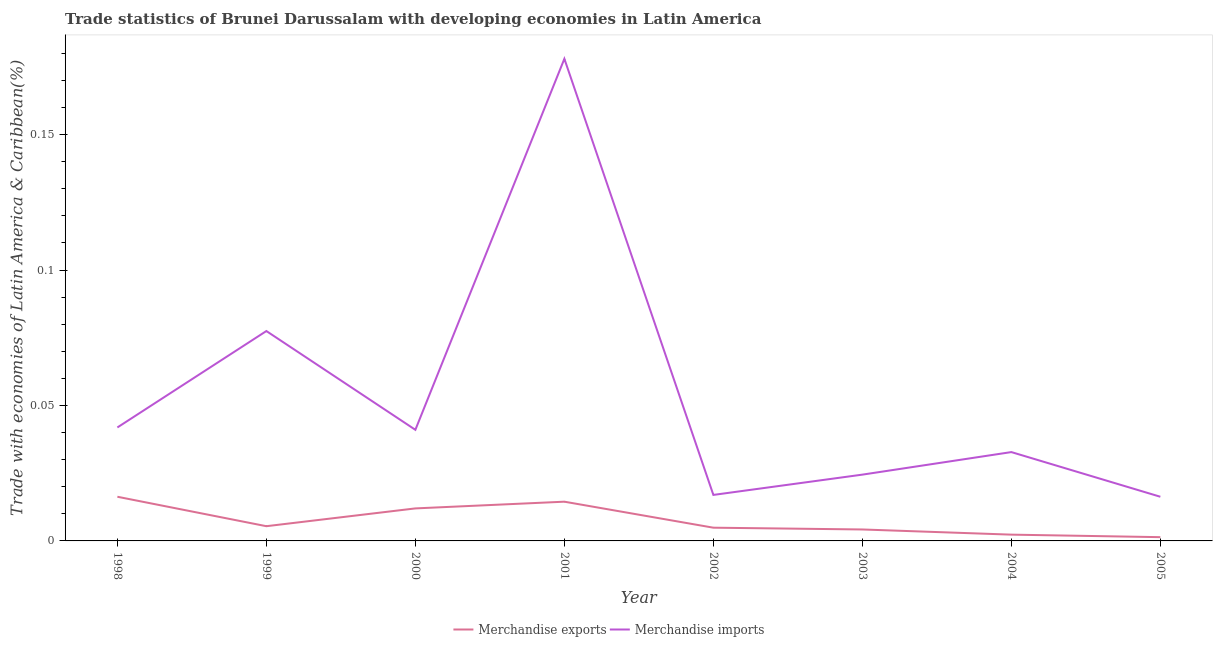Is the number of lines equal to the number of legend labels?
Your answer should be compact. Yes. What is the merchandise imports in 2000?
Ensure brevity in your answer.  0.04. Across all years, what is the maximum merchandise exports?
Your answer should be very brief. 0.02. Across all years, what is the minimum merchandise imports?
Make the answer very short. 0.02. What is the total merchandise imports in the graph?
Provide a succinct answer. 0.43. What is the difference between the merchandise imports in 1999 and that in 2000?
Keep it short and to the point. 0.04. What is the difference between the merchandise imports in 2002 and the merchandise exports in 2001?
Keep it short and to the point. 0. What is the average merchandise exports per year?
Your answer should be compact. 0.01. In the year 2004, what is the difference between the merchandise exports and merchandise imports?
Offer a terse response. -0.03. What is the ratio of the merchandise imports in 2001 to that in 2003?
Provide a short and direct response. 7.27. Is the merchandise exports in 2000 less than that in 2002?
Your answer should be compact. No. What is the difference between the highest and the second highest merchandise imports?
Offer a very short reply. 0.1. What is the difference between the highest and the lowest merchandise exports?
Ensure brevity in your answer.  0.01. In how many years, is the merchandise exports greater than the average merchandise exports taken over all years?
Ensure brevity in your answer.  3. Is the sum of the merchandise imports in 1999 and 2004 greater than the maximum merchandise exports across all years?
Provide a succinct answer. Yes. Is the merchandise exports strictly greater than the merchandise imports over the years?
Provide a short and direct response. No. Is the merchandise imports strictly less than the merchandise exports over the years?
Make the answer very short. No. How many lines are there?
Your answer should be very brief. 2. How many years are there in the graph?
Give a very brief answer. 8. What is the difference between two consecutive major ticks on the Y-axis?
Provide a short and direct response. 0.05. Where does the legend appear in the graph?
Make the answer very short. Bottom center. How are the legend labels stacked?
Provide a succinct answer. Horizontal. What is the title of the graph?
Offer a terse response. Trade statistics of Brunei Darussalam with developing economies in Latin America. Does "Fixed telephone" appear as one of the legend labels in the graph?
Give a very brief answer. No. What is the label or title of the Y-axis?
Offer a terse response. Trade with economies of Latin America & Caribbean(%). What is the Trade with economies of Latin America & Caribbean(%) of Merchandise exports in 1998?
Offer a very short reply. 0.02. What is the Trade with economies of Latin America & Caribbean(%) in Merchandise imports in 1998?
Ensure brevity in your answer.  0.04. What is the Trade with economies of Latin America & Caribbean(%) in Merchandise exports in 1999?
Offer a terse response. 0.01. What is the Trade with economies of Latin America & Caribbean(%) in Merchandise imports in 1999?
Make the answer very short. 0.08. What is the Trade with economies of Latin America & Caribbean(%) of Merchandise exports in 2000?
Provide a short and direct response. 0.01. What is the Trade with economies of Latin America & Caribbean(%) in Merchandise imports in 2000?
Your response must be concise. 0.04. What is the Trade with economies of Latin America & Caribbean(%) of Merchandise exports in 2001?
Provide a succinct answer. 0.01. What is the Trade with economies of Latin America & Caribbean(%) in Merchandise imports in 2001?
Give a very brief answer. 0.18. What is the Trade with economies of Latin America & Caribbean(%) of Merchandise exports in 2002?
Provide a short and direct response. 0. What is the Trade with economies of Latin America & Caribbean(%) in Merchandise imports in 2002?
Provide a short and direct response. 0.02. What is the Trade with economies of Latin America & Caribbean(%) in Merchandise exports in 2003?
Your answer should be compact. 0. What is the Trade with economies of Latin America & Caribbean(%) of Merchandise imports in 2003?
Ensure brevity in your answer.  0.02. What is the Trade with economies of Latin America & Caribbean(%) in Merchandise exports in 2004?
Offer a very short reply. 0. What is the Trade with economies of Latin America & Caribbean(%) in Merchandise imports in 2004?
Offer a very short reply. 0.03. What is the Trade with economies of Latin America & Caribbean(%) in Merchandise exports in 2005?
Ensure brevity in your answer.  0. What is the Trade with economies of Latin America & Caribbean(%) in Merchandise imports in 2005?
Your response must be concise. 0.02. Across all years, what is the maximum Trade with economies of Latin America & Caribbean(%) of Merchandise exports?
Offer a very short reply. 0.02. Across all years, what is the maximum Trade with economies of Latin America & Caribbean(%) in Merchandise imports?
Give a very brief answer. 0.18. Across all years, what is the minimum Trade with economies of Latin America & Caribbean(%) of Merchandise exports?
Keep it short and to the point. 0. Across all years, what is the minimum Trade with economies of Latin America & Caribbean(%) of Merchandise imports?
Provide a short and direct response. 0.02. What is the total Trade with economies of Latin America & Caribbean(%) in Merchandise exports in the graph?
Provide a succinct answer. 0.06. What is the total Trade with economies of Latin America & Caribbean(%) of Merchandise imports in the graph?
Offer a very short reply. 0.43. What is the difference between the Trade with economies of Latin America & Caribbean(%) of Merchandise exports in 1998 and that in 1999?
Your response must be concise. 0.01. What is the difference between the Trade with economies of Latin America & Caribbean(%) in Merchandise imports in 1998 and that in 1999?
Your answer should be very brief. -0.04. What is the difference between the Trade with economies of Latin America & Caribbean(%) in Merchandise exports in 1998 and that in 2000?
Your answer should be very brief. 0. What is the difference between the Trade with economies of Latin America & Caribbean(%) in Merchandise imports in 1998 and that in 2000?
Ensure brevity in your answer.  0. What is the difference between the Trade with economies of Latin America & Caribbean(%) of Merchandise exports in 1998 and that in 2001?
Provide a succinct answer. 0. What is the difference between the Trade with economies of Latin America & Caribbean(%) in Merchandise imports in 1998 and that in 2001?
Offer a very short reply. -0.14. What is the difference between the Trade with economies of Latin America & Caribbean(%) in Merchandise exports in 1998 and that in 2002?
Ensure brevity in your answer.  0.01. What is the difference between the Trade with economies of Latin America & Caribbean(%) in Merchandise imports in 1998 and that in 2002?
Provide a succinct answer. 0.02. What is the difference between the Trade with economies of Latin America & Caribbean(%) of Merchandise exports in 1998 and that in 2003?
Provide a short and direct response. 0.01. What is the difference between the Trade with economies of Latin America & Caribbean(%) in Merchandise imports in 1998 and that in 2003?
Ensure brevity in your answer.  0.02. What is the difference between the Trade with economies of Latin America & Caribbean(%) in Merchandise exports in 1998 and that in 2004?
Your answer should be very brief. 0.01. What is the difference between the Trade with economies of Latin America & Caribbean(%) of Merchandise imports in 1998 and that in 2004?
Your answer should be very brief. 0.01. What is the difference between the Trade with economies of Latin America & Caribbean(%) of Merchandise exports in 1998 and that in 2005?
Ensure brevity in your answer.  0.01. What is the difference between the Trade with economies of Latin America & Caribbean(%) of Merchandise imports in 1998 and that in 2005?
Keep it short and to the point. 0.03. What is the difference between the Trade with economies of Latin America & Caribbean(%) in Merchandise exports in 1999 and that in 2000?
Your response must be concise. -0.01. What is the difference between the Trade with economies of Latin America & Caribbean(%) in Merchandise imports in 1999 and that in 2000?
Provide a short and direct response. 0.04. What is the difference between the Trade with economies of Latin America & Caribbean(%) in Merchandise exports in 1999 and that in 2001?
Provide a succinct answer. -0.01. What is the difference between the Trade with economies of Latin America & Caribbean(%) in Merchandise imports in 1999 and that in 2001?
Make the answer very short. -0.1. What is the difference between the Trade with economies of Latin America & Caribbean(%) in Merchandise exports in 1999 and that in 2002?
Your answer should be compact. 0. What is the difference between the Trade with economies of Latin America & Caribbean(%) in Merchandise imports in 1999 and that in 2002?
Your answer should be compact. 0.06. What is the difference between the Trade with economies of Latin America & Caribbean(%) of Merchandise exports in 1999 and that in 2003?
Your answer should be compact. 0. What is the difference between the Trade with economies of Latin America & Caribbean(%) of Merchandise imports in 1999 and that in 2003?
Your response must be concise. 0.05. What is the difference between the Trade with economies of Latin America & Caribbean(%) of Merchandise exports in 1999 and that in 2004?
Offer a very short reply. 0. What is the difference between the Trade with economies of Latin America & Caribbean(%) of Merchandise imports in 1999 and that in 2004?
Offer a terse response. 0.04. What is the difference between the Trade with economies of Latin America & Caribbean(%) in Merchandise exports in 1999 and that in 2005?
Make the answer very short. 0. What is the difference between the Trade with economies of Latin America & Caribbean(%) in Merchandise imports in 1999 and that in 2005?
Ensure brevity in your answer.  0.06. What is the difference between the Trade with economies of Latin America & Caribbean(%) in Merchandise exports in 2000 and that in 2001?
Offer a terse response. -0. What is the difference between the Trade with economies of Latin America & Caribbean(%) in Merchandise imports in 2000 and that in 2001?
Keep it short and to the point. -0.14. What is the difference between the Trade with economies of Latin America & Caribbean(%) in Merchandise exports in 2000 and that in 2002?
Provide a short and direct response. 0.01. What is the difference between the Trade with economies of Latin America & Caribbean(%) in Merchandise imports in 2000 and that in 2002?
Your answer should be very brief. 0.02. What is the difference between the Trade with economies of Latin America & Caribbean(%) in Merchandise exports in 2000 and that in 2003?
Offer a very short reply. 0.01. What is the difference between the Trade with economies of Latin America & Caribbean(%) of Merchandise imports in 2000 and that in 2003?
Provide a succinct answer. 0.02. What is the difference between the Trade with economies of Latin America & Caribbean(%) of Merchandise exports in 2000 and that in 2004?
Offer a very short reply. 0.01. What is the difference between the Trade with economies of Latin America & Caribbean(%) of Merchandise imports in 2000 and that in 2004?
Your answer should be very brief. 0.01. What is the difference between the Trade with economies of Latin America & Caribbean(%) in Merchandise exports in 2000 and that in 2005?
Your answer should be very brief. 0.01. What is the difference between the Trade with economies of Latin America & Caribbean(%) of Merchandise imports in 2000 and that in 2005?
Provide a succinct answer. 0.02. What is the difference between the Trade with economies of Latin America & Caribbean(%) of Merchandise exports in 2001 and that in 2002?
Give a very brief answer. 0.01. What is the difference between the Trade with economies of Latin America & Caribbean(%) in Merchandise imports in 2001 and that in 2002?
Give a very brief answer. 0.16. What is the difference between the Trade with economies of Latin America & Caribbean(%) of Merchandise exports in 2001 and that in 2003?
Provide a succinct answer. 0.01. What is the difference between the Trade with economies of Latin America & Caribbean(%) of Merchandise imports in 2001 and that in 2003?
Give a very brief answer. 0.15. What is the difference between the Trade with economies of Latin America & Caribbean(%) in Merchandise exports in 2001 and that in 2004?
Your answer should be very brief. 0.01. What is the difference between the Trade with economies of Latin America & Caribbean(%) of Merchandise imports in 2001 and that in 2004?
Offer a terse response. 0.15. What is the difference between the Trade with economies of Latin America & Caribbean(%) of Merchandise exports in 2001 and that in 2005?
Provide a succinct answer. 0.01. What is the difference between the Trade with economies of Latin America & Caribbean(%) in Merchandise imports in 2001 and that in 2005?
Give a very brief answer. 0.16. What is the difference between the Trade with economies of Latin America & Caribbean(%) in Merchandise exports in 2002 and that in 2003?
Your response must be concise. 0. What is the difference between the Trade with economies of Latin America & Caribbean(%) of Merchandise imports in 2002 and that in 2003?
Offer a terse response. -0.01. What is the difference between the Trade with economies of Latin America & Caribbean(%) of Merchandise exports in 2002 and that in 2004?
Ensure brevity in your answer.  0. What is the difference between the Trade with economies of Latin America & Caribbean(%) in Merchandise imports in 2002 and that in 2004?
Provide a succinct answer. -0.02. What is the difference between the Trade with economies of Latin America & Caribbean(%) of Merchandise exports in 2002 and that in 2005?
Provide a short and direct response. 0. What is the difference between the Trade with economies of Latin America & Caribbean(%) in Merchandise imports in 2002 and that in 2005?
Offer a very short reply. 0. What is the difference between the Trade with economies of Latin America & Caribbean(%) of Merchandise exports in 2003 and that in 2004?
Provide a succinct answer. 0. What is the difference between the Trade with economies of Latin America & Caribbean(%) in Merchandise imports in 2003 and that in 2004?
Offer a terse response. -0.01. What is the difference between the Trade with economies of Latin America & Caribbean(%) of Merchandise exports in 2003 and that in 2005?
Provide a short and direct response. 0. What is the difference between the Trade with economies of Latin America & Caribbean(%) in Merchandise imports in 2003 and that in 2005?
Provide a succinct answer. 0.01. What is the difference between the Trade with economies of Latin America & Caribbean(%) of Merchandise exports in 2004 and that in 2005?
Your answer should be compact. 0. What is the difference between the Trade with economies of Latin America & Caribbean(%) in Merchandise imports in 2004 and that in 2005?
Your answer should be compact. 0.02. What is the difference between the Trade with economies of Latin America & Caribbean(%) of Merchandise exports in 1998 and the Trade with economies of Latin America & Caribbean(%) of Merchandise imports in 1999?
Your answer should be compact. -0.06. What is the difference between the Trade with economies of Latin America & Caribbean(%) of Merchandise exports in 1998 and the Trade with economies of Latin America & Caribbean(%) of Merchandise imports in 2000?
Give a very brief answer. -0.02. What is the difference between the Trade with economies of Latin America & Caribbean(%) of Merchandise exports in 1998 and the Trade with economies of Latin America & Caribbean(%) of Merchandise imports in 2001?
Provide a succinct answer. -0.16. What is the difference between the Trade with economies of Latin America & Caribbean(%) in Merchandise exports in 1998 and the Trade with economies of Latin America & Caribbean(%) in Merchandise imports in 2002?
Your answer should be very brief. -0. What is the difference between the Trade with economies of Latin America & Caribbean(%) of Merchandise exports in 1998 and the Trade with economies of Latin America & Caribbean(%) of Merchandise imports in 2003?
Keep it short and to the point. -0.01. What is the difference between the Trade with economies of Latin America & Caribbean(%) in Merchandise exports in 1998 and the Trade with economies of Latin America & Caribbean(%) in Merchandise imports in 2004?
Keep it short and to the point. -0.02. What is the difference between the Trade with economies of Latin America & Caribbean(%) in Merchandise exports in 1998 and the Trade with economies of Latin America & Caribbean(%) in Merchandise imports in 2005?
Make the answer very short. 0. What is the difference between the Trade with economies of Latin America & Caribbean(%) of Merchandise exports in 1999 and the Trade with economies of Latin America & Caribbean(%) of Merchandise imports in 2000?
Your response must be concise. -0.04. What is the difference between the Trade with economies of Latin America & Caribbean(%) of Merchandise exports in 1999 and the Trade with economies of Latin America & Caribbean(%) of Merchandise imports in 2001?
Offer a very short reply. -0.17. What is the difference between the Trade with economies of Latin America & Caribbean(%) in Merchandise exports in 1999 and the Trade with economies of Latin America & Caribbean(%) in Merchandise imports in 2002?
Your answer should be very brief. -0.01. What is the difference between the Trade with economies of Latin America & Caribbean(%) in Merchandise exports in 1999 and the Trade with economies of Latin America & Caribbean(%) in Merchandise imports in 2003?
Provide a short and direct response. -0.02. What is the difference between the Trade with economies of Latin America & Caribbean(%) of Merchandise exports in 1999 and the Trade with economies of Latin America & Caribbean(%) of Merchandise imports in 2004?
Make the answer very short. -0.03. What is the difference between the Trade with economies of Latin America & Caribbean(%) of Merchandise exports in 1999 and the Trade with economies of Latin America & Caribbean(%) of Merchandise imports in 2005?
Offer a terse response. -0.01. What is the difference between the Trade with economies of Latin America & Caribbean(%) in Merchandise exports in 2000 and the Trade with economies of Latin America & Caribbean(%) in Merchandise imports in 2001?
Give a very brief answer. -0.17. What is the difference between the Trade with economies of Latin America & Caribbean(%) in Merchandise exports in 2000 and the Trade with economies of Latin America & Caribbean(%) in Merchandise imports in 2002?
Offer a terse response. -0.01. What is the difference between the Trade with economies of Latin America & Caribbean(%) in Merchandise exports in 2000 and the Trade with economies of Latin America & Caribbean(%) in Merchandise imports in 2003?
Your response must be concise. -0.01. What is the difference between the Trade with economies of Latin America & Caribbean(%) in Merchandise exports in 2000 and the Trade with economies of Latin America & Caribbean(%) in Merchandise imports in 2004?
Your answer should be very brief. -0.02. What is the difference between the Trade with economies of Latin America & Caribbean(%) in Merchandise exports in 2000 and the Trade with economies of Latin America & Caribbean(%) in Merchandise imports in 2005?
Offer a very short reply. -0. What is the difference between the Trade with economies of Latin America & Caribbean(%) in Merchandise exports in 2001 and the Trade with economies of Latin America & Caribbean(%) in Merchandise imports in 2002?
Make the answer very short. -0. What is the difference between the Trade with economies of Latin America & Caribbean(%) in Merchandise exports in 2001 and the Trade with economies of Latin America & Caribbean(%) in Merchandise imports in 2003?
Ensure brevity in your answer.  -0.01. What is the difference between the Trade with economies of Latin America & Caribbean(%) in Merchandise exports in 2001 and the Trade with economies of Latin America & Caribbean(%) in Merchandise imports in 2004?
Make the answer very short. -0.02. What is the difference between the Trade with economies of Latin America & Caribbean(%) in Merchandise exports in 2001 and the Trade with economies of Latin America & Caribbean(%) in Merchandise imports in 2005?
Give a very brief answer. -0. What is the difference between the Trade with economies of Latin America & Caribbean(%) in Merchandise exports in 2002 and the Trade with economies of Latin America & Caribbean(%) in Merchandise imports in 2003?
Your answer should be very brief. -0.02. What is the difference between the Trade with economies of Latin America & Caribbean(%) of Merchandise exports in 2002 and the Trade with economies of Latin America & Caribbean(%) of Merchandise imports in 2004?
Your response must be concise. -0.03. What is the difference between the Trade with economies of Latin America & Caribbean(%) of Merchandise exports in 2002 and the Trade with economies of Latin America & Caribbean(%) of Merchandise imports in 2005?
Your answer should be very brief. -0.01. What is the difference between the Trade with economies of Latin America & Caribbean(%) in Merchandise exports in 2003 and the Trade with economies of Latin America & Caribbean(%) in Merchandise imports in 2004?
Make the answer very short. -0.03. What is the difference between the Trade with economies of Latin America & Caribbean(%) in Merchandise exports in 2003 and the Trade with economies of Latin America & Caribbean(%) in Merchandise imports in 2005?
Keep it short and to the point. -0.01. What is the difference between the Trade with economies of Latin America & Caribbean(%) in Merchandise exports in 2004 and the Trade with economies of Latin America & Caribbean(%) in Merchandise imports in 2005?
Offer a very short reply. -0.01. What is the average Trade with economies of Latin America & Caribbean(%) in Merchandise exports per year?
Give a very brief answer. 0.01. What is the average Trade with economies of Latin America & Caribbean(%) in Merchandise imports per year?
Offer a very short reply. 0.05. In the year 1998, what is the difference between the Trade with economies of Latin America & Caribbean(%) of Merchandise exports and Trade with economies of Latin America & Caribbean(%) of Merchandise imports?
Offer a very short reply. -0.03. In the year 1999, what is the difference between the Trade with economies of Latin America & Caribbean(%) in Merchandise exports and Trade with economies of Latin America & Caribbean(%) in Merchandise imports?
Provide a short and direct response. -0.07. In the year 2000, what is the difference between the Trade with economies of Latin America & Caribbean(%) in Merchandise exports and Trade with economies of Latin America & Caribbean(%) in Merchandise imports?
Your answer should be compact. -0.03. In the year 2001, what is the difference between the Trade with economies of Latin America & Caribbean(%) in Merchandise exports and Trade with economies of Latin America & Caribbean(%) in Merchandise imports?
Your response must be concise. -0.16. In the year 2002, what is the difference between the Trade with economies of Latin America & Caribbean(%) in Merchandise exports and Trade with economies of Latin America & Caribbean(%) in Merchandise imports?
Offer a terse response. -0.01. In the year 2003, what is the difference between the Trade with economies of Latin America & Caribbean(%) of Merchandise exports and Trade with economies of Latin America & Caribbean(%) of Merchandise imports?
Your response must be concise. -0.02. In the year 2004, what is the difference between the Trade with economies of Latin America & Caribbean(%) in Merchandise exports and Trade with economies of Latin America & Caribbean(%) in Merchandise imports?
Give a very brief answer. -0.03. In the year 2005, what is the difference between the Trade with economies of Latin America & Caribbean(%) in Merchandise exports and Trade with economies of Latin America & Caribbean(%) in Merchandise imports?
Your answer should be very brief. -0.01. What is the ratio of the Trade with economies of Latin America & Caribbean(%) in Merchandise exports in 1998 to that in 1999?
Give a very brief answer. 3. What is the ratio of the Trade with economies of Latin America & Caribbean(%) of Merchandise imports in 1998 to that in 1999?
Give a very brief answer. 0.54. What is the ratio of the Trade with economies of Latin America & Caribbean(%) of Merchandise exports in 1998 to that in 2000?
Keep it short and to the point. 1.36. What is the ratio of the Trade with economies of Latin America & Caribbean(%) of Merchandise imports in 1998 to that in 2000?
Provide a short and direct response. 1.02. What is the ratio of the Trade with economies of Latin America & Caribbean(%) in Merchandise exports in 1998 to that in 2001?
Your response must be concise. 1.13. What is the ratio of the Trade with economies of Latin America & Caribbean(%) in Merchandise imports in 1998 to that in 2001?
Give a very brief answer. 0.24. What is the ratio of the Trade with economies of Latin America & Caribbean(%) of Merchandise exports in 1998 to that in 2002?
Your response must be concise. 3.34. What is the ratio of the Trade with economies of Latin America & Caribbean(%) of Merchandise imports in 1998 to that in 2002?
Make the answer very short. 2.47. What is the ratio of the Trade with economies of Latin America & Caribbean(%) of Merchandise exports in 1998 to that in 2003?
Your answer should be compact. 3.86. What is the ratio of the Trade with economies of Latin America & Caribbean(%) in Merchandise imports in 1998 to that in 2003?
Make the answer very short. 1.71. What is the ratio of the Trade with economies of Latin America & Caribbean(%) in Merchandise exports in 1998 to that in 2004?
Make the answer very short. 7.04. What is the ratio of the Trade with economies of Latin America & Caribbean(%) of Merchandise imports in 1998 to that in 2004?
Provide a succinct answer. 1.28. What is the ratio of the Trade with economies of Latin America & Caribbean(%) in Merchandise exports in 1998 to that in 2005?
Your answer should be compact. 11.74. What is the ratio of the Trade with economies of Latin America & Caribbean(%) of Merchandise imports in 1998 to that in 2005?
Make the answer very short. 2.57. What is the ratio of the Trade with economies of Latin America & Caribbean(%) of Merchandise exports in 1999 to that in 2000?
Your answer should be very brief. 0.45. What is the ratio of the Trade with economies of Latin America & Caribbean(%) of Merchandise imports in 1999 to that in 2000?
Provide a succinct answer. 1.89. What is the ratio of the Trade with economies of Latin America & Caribbean(%) in Merchandise exports in 1999 to that in 2001?
Your answer should be very brief. 0.38. What is the ratio of the Trade with economies of Latin America & Caribbean(%) of Merchandise imports in 1999 to that in 2001?
Provide a succinct answer. 0.44. What is the ratio of the Trade with economies of Latin America & Caribbean(%) in Merchandise exports in 1999 to that in 2002?
Your answer should be very brief. 1.11. What is the ratio of the Trade with economies of Latin America & Caribbean(%) in Merchandise imports in 1999 to that in 2002?
Give a very brief answer. 4.56. What is the ratio of the Trade with economies of Latin America & Caribbean(%) of Merchandise exports in 1999 to that in 2003?
Keep it short and to the point. 1.29. What is the ratio of the Trade with economies of Latin America & Caribbean(%) of Merchandise imports in 1999 to that in 2003?
Give a very brief answer. 3.17. What is the ratio of the Trade with economies of Latin America & Caribbean(%) in Merchandise exports in 1999 to that in 2004?
Your response must be concise. 2.34. What is the ratio of the Trade with economies of Latin America & Caribbean(%) of Merchandise imports in 1999 to that in 2004?
Offer a terse response. 2.36. What is the ratio of the Trade with economies of Latin America & Caribbean(%) in Merchandise exports in 1999 to that in 2005?
Offer a terse response. 3.91. What is the ratio of the Trade with economies of Latin America & Caribbean(%) of Merchandise imports in 1999 to that in 2005?
Your answer should be very brief. 4.75. What is the ratio of the Trade with economies of Latin America & Caribbean(%) in Merchandise exports in 2000 to that in 2001?
Keep it short and to the point. 0.83. What is the ratio of the Trade with economies of Latin America & Caribbean(%) of Merchandise imports in 2000 to that in 2001?
Make the answer very short. 0.23. What is the ratio of the Trade with economies of Latin America & Caribbean(%) of Merchandise exports in 2000 to that in 2002?
Provide a short and direct response. 2.46. What is the ratio of the Trade with economies of Latin America & Caribbean(%) of Merchandise imports in 2000 to that in 2002?
Your answer should be very brief. 2.42. What is the ratio of the Trade with economies of Latin America & Caribbean(%) in Merchandise exports in 2000 to that in 2003?
Your response must be concise. 2.84. What is the ratio of the Trade with economies of Latin America & Caribbean(%) of Merchandise imports in 2000 to that in 2003?
Offer a terse response. 1.68. What is the ratio of the Trade with economies of Latin America & Caribbean(%) in Merchandise exports in 2000 to that in 2004?
Ensure brevity in your answer.  5.18. What is the ratio of the Trade with economies of Latin America & Caribbean(%) of Merchandise imports in 2000 to that in 2004?
Make the answer very short. 1.25. What is the ratio of the Trade with economies of Latin America & Caribbean(%) of Merchandise exports in 2000 to that in 2005?
Keep it short and to the point. 8.64. What is the ratio of the Trade with economies of Latin America & Caribbean(%) of Merchandise imports in 2000 to that in 2005?
Keep it short and to the point. 2.52. What is the ratio of the Trade with economies of Latin America & Caribbean(%) of Merchandise exports in 2001 to that in 2002?
Make the answer very short. 2.97. What is the ratio of the Trade with economies of Latin America & Caribbean(%) in Merchandise imports in 2001 to that in 2002?
Keep it short and to the point. 10.48. What is the ratio of the Trade with economies of Latin America & Caribbean(%) of Merchandise exports in 2001 to that in 2003?
Your response must be concise. 3.43. What is the ratio of the Trade with economies of Latin America & Caribbean(%) in Merchandise imports in 2001 to that in 2003?
Give a very brief answer. 7.27. What is the ratio of the Trade with economies of Latin America & Caribbean(%) in Merchandise exports in 2001 to that in 2004?
Provide a succinct answer. 6.25. What is the ratio of the Trade with economies of Latin America & Caribbean(%) in Merchandise imports in 2001 to that in 2004?
Your response must be concise. 5.43. What is the ratio of the Trade with economies of Latin America & Caribbean(%) of Merchandise exports in 2001 to that in 2005?
Offer a terse response. 10.43. What is the ratio of the Trade with economies of Latin America & Caribbean(%) in Merchandise imports in 2001 to that in 2005?
Offer a terse response. 10.92. What is the ratio of the Trade with economies of Latin America & Caribbean(%) of Merchandise exports in 2002 to that in 2003?
Provide a short and direct response. 1.16. What is the ratio of the Trade with economies of Latin America & Caribbean(%) of Merchandise imports in 2002 to that in 2003?
Make the answer very short. 0.69. What is the ratio of the Trade with economies of Latin America & Caribbean(%) of Merchandise exports in 2002 to that in 2004?
Offer a very short reply. 2.11. What is the ratio of the Trade with economies of Latin America & Caribbean(%) in Merchandise imports in 2002 to that in 2004?
Provide a short and direct response. 0.52. What is the ratio of the Trade with economies of Latin America & Caribbean(%) in Merchandise exports in 2002 to that in 2005?
Your answer should be very brief. 3.52. What is the ratio of the Trade with economies of Latin America & Caribbean(%) in Merchandise imports in 2002 to that in 2005?
Provide a succinct answer. 1.04. What is the ratio of the Trade with economies of Latin America & Caribbean(%) of Merchandise exports in 2003 to that in 2004?
Provide a succinct answer. 1.82. What is the ratio of the Trade with economies of Latin America & Caribbean(%) of Merchandise imports in 2003 to that in 2004?
Give a very brief answer. 0.75. What is the ratio of the Trade with economies of Latin America & Caribbean(%) of Merchandise exports in 2003 to that in 2005?
Keep it short and to the point. 3.04. What is the ratio of the Trade with economies of Latin America & Caribbean(%) of Merchandise imports in 2003 to that in 2005?
Give a very brief answer. 1.5. What is the ratio of the Trade with economies of Latin America & Caribbean(%) in Merchandise exports in 2004 to that in 2005?
Offer a very short reply. 1.67. What is the ratio of the Trade with economies of Latin America & Caribbean(%) of Merchandise imports in 2004 to that in 2005?
Make the answer very short. 2.01. What is the difference between the highest and the second highest Trade with economies of Latin America & Caribbean(%) in Merchandise exports?
Offer a terse response. 0. What is the difference between the highest and the second highest Trade with economies of Latin America & Caribbean(%) of Merchandise imports?
Your response must be concise. 0.1. What is the difference between the highest and the lowest Trade with economies of Latin America & Caribbean(%) in Merchandise exports?
Ensure brevity in your answer.  0.01. What is the difference between the highest and the lowest Trade with economies of Latin America & Caribbean(%) in Merchandise imports?
Your answer should be very brief. 0.16. 